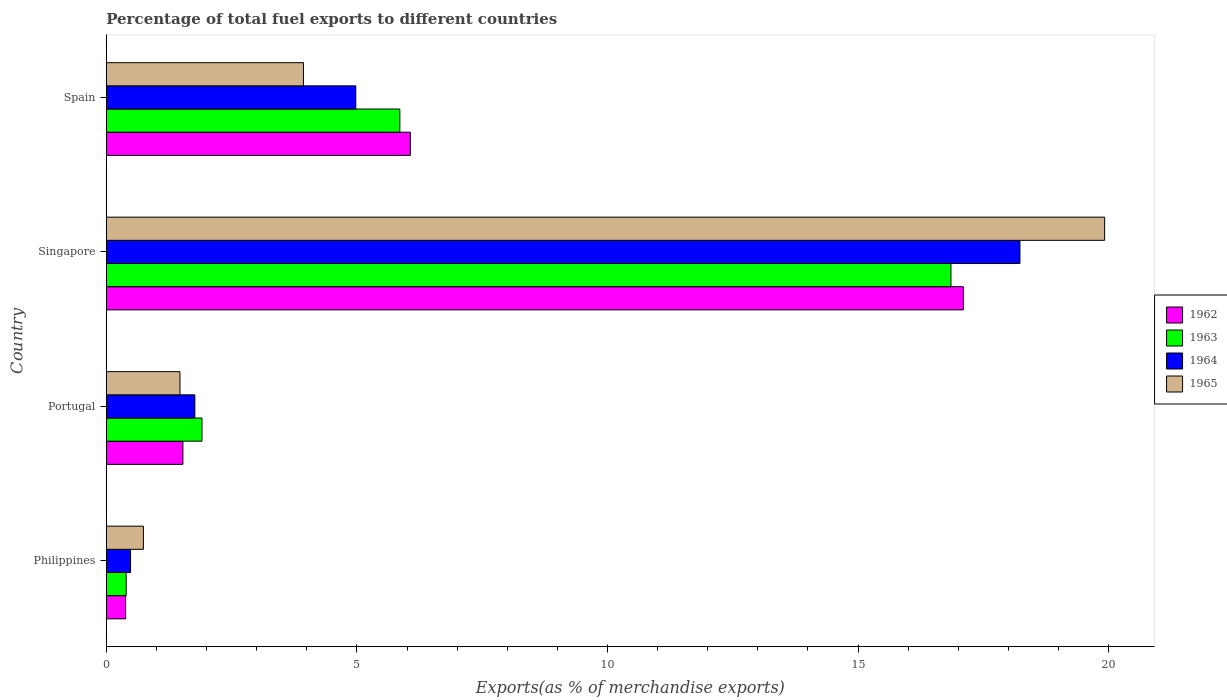How many different coloured bars are there?
Your answer should be very brief. 4. Are the number of bars per tick equal to the number of legend labels?
Ensure brevity in your answer.  Yes. How many bars are there on the 1st tick from the top?
Offer a terse response. 4. How many bars are there on the 3rd tick from the bottom?
Ensure brevity in your answer.  4. What is the label of the 2nd group of bars from the top?
Ensure brevity in your answer.  Singapore. What is the percentage of exports to different countries in 1962 in Philippines?
Give a very brief answer. 0.38. Across all countries, what is the maximum percentage of exports to different countries in 1965?
Offer a terse response. 19.92. Across all countries, what is the minimum percentage of exports to different countries in 1962?
Ensure brevity in your answer.  0.38. In which country was the percentage of exports to different countries in 1963 maximum?
Offer a terse response. Singapore. What is the total percentage of exports to different countries in 1965 in the graph?
Your answer should be compact. 26.06. What is the difference between the percentage of exports to different countries in 1965 in Philippines and that in Portugal?
Your response must be concise. -0.73. What is the difference between the percentage of exports to different countries in 1964 in Portugal and the percentage of exports to different countries in 1963 in Philippines?
Your answer should be compact. 1.37. What is the average percentage of exports to different countries in 1962 per country?
Provide a short and direct response. 6.27. What is the difference between the percentage of exports to different countries in 1964 and percentage of exports to different countries in 1965 in Portugal?
Offer a terse response. 0.3. What is the ratio of the percentage of exports to different countries in 1963 in Philippines to that in Spain?
Make the answer very short. 0.07. Is the percentage of exports to different countries in 1965 in Portugal less than that in Spain?
Your answer should be very brief. Yes. What is the difference between the highest and the second highest percentage of exports to different countries in 1962?
Provide a succinct answer. 11.04. What is the difference between the highest and the lowest percentage of exports to different countries in 1964?
Your answer should be very brief. 17.75. Is the sum of the percentage of exports to different countries in 1962 in Portugal and Singapore greater than the maximum percentage of exports to different countries in 1964 across all countries?
Your answer should be compact. Yes. Is it the case that in every country, the sum of the percentage of exports to different countries in 1962 and percentage of exports to different countries in 1963 is greater than the sum of percentage of exports to different countries in 1964 and percentage of exports to different countries in 1965?
Offer a terse response. No. What does the 4th bar from the bottom in Portugal represents?
Give a very brief answer. 1965. How many bars are there?
Your answer should be very brief. 16. Are all the bars in the graph horizontal?
Provide a short and direct response. Yes. What is the difference between two consecutive major ticks on the X-axis?
Provide a short and direct response. 5. Are the values on the major ticks of X-axis written in scientific E-notation?
Offer a terse response. No. Does the graph contain any zero values?
Your answer should be compact. No. Where does the legend appear in the graph?
Your response must be concise. Center right. What is the title of the graph?
Offer a very short reply. Percentage of total fuel exports to different countries. Does "2013" appear as one of the legend labels in the graph?
Give a very brief answer. No. What is the label or title of the X-axis?
Keep it short and to the point. Exports(as % of merchandise exports). What is the label or title of the Y-axis?
Provide a short and direct response. Country. What is the Exports(as % of merchandise exports) of 1962 in Philippines?
Offer a very short reply. 0.38. What is the Exports(as % of merchandise exports) of 1963 in Philippines?
Give a very brief answer. 0.4. What is the Exports(as % of merchandise exports) of 1964 in Philippines?
Your response must be concise. 0.48. What is the Exports(as % of merchandise exports) of 1965 in Philippines?
Make the answer very short. 0.74. What is the Exports(as % of merchandise exports) of 1962 in Portugal?
Your response must be concise. 1.53. What is the Exports(as % of merchandise exports) of 1963 in Portugal?
Offer a terse response. 1.91. What is the Exports(as % of merchandise exports) of 1964 in Portugal?
Give a very brief answer. 1.77. What is the Exports(as % of merchandise exports) of 1965 in Portugal?
Keep it short and to the point. 1.47. What is the Exports(as % of merchandise exports) in 1962 in Singapore?
Ensure brevity in your answer.  17.1. What is the Exports(as % of merchandise exports) of 1963 in Singapore?
Your response must be concise. 16.85. What is the Exports(as % of merchandise exports) of 1964 in Singapore?
Give a very brief answer. 18.23. What is the Exports(as % of merchandise exports) of 1965 in Singapore?
Offer a very short reply. 19.92. What is the Exports(as % of merchandise exports) of 1962 in Spain?
Offer a terse response. 6.07. What is the Exports(as % of merchandise exports) in 1963 in Spain?
Provide a succinct answer. 5.86. What is the Exports(as % of merchandise exports) of 1964 in Spain?
Your response must be concise. 4.98. What is the Exports(as % of merchandise exports) in 1965 in Spain?
Your answer should be compact. 3.93. Across all countries, what is the maximum Exports(as % of merchandise exports) of 1962?
Your answer should be compact. 17.1. Across all countries, what is the maximum Exports(as % of merchandise exports) of 1963?
Provide a succinct answer. 16.85. Across all countries, what is the maximum Exports(as % of merchandise exports) in 1964?
Offer a very short reply. 18.23. Across all countries, what is the maximum Exports(as % of merchandise exports) of 1965?
Keep it short and to the point. 19.92. Across all countries, what is the minimum Exports(as % of merchandise exports) of 1962?
Give a very brief answer. 0.38. Across all countries, what is the minimum Exports(as % of merchandise exports) of 1963?
Make the answer very short. 0.4. Across all countries, what is the minimum Exports(as % of merchandise exports) in 1964?
Offer a terse response. 0.48. Across all countries, what is the minimum Exports(as % of merchandise exports) of 1965?
Keep it short and to the point. 0.74. What is the total Exports(as % of merchandise exports) of 1962 in the graph?
Give a very brief answer. 25.08. What is the total Exports(as % of merchandise exports) in 1963 in the graph?
Ensure brevity in your answer.  25.02. What is the total Exports(as % of merchandise exports) in 1964 in the graph?
Give a very brief answer. 25.46. What is the total Exports(as % of merchandise exports) in 1965 in the graph?
Keep it short and to the point. 26.07. What is the difference between the Exports(as % of merchandise exports) in 1962 in Philippines and that in Portugal?
Your response must be concise. -1.14. What is the difference between the Exports(as % of merchandise exports) in 1963 in Philippines and that in Portugal?
Make the answer very short. -1.51. What is the difference between the Exports(as % of merchandise exports) of 1964 in Philippines and that in Portugal?
Your response must be concise. -1.28. What is the difference between the Exports(as % of merchandise exports) of 1965 in Philippines and that in Portugal?
Your answer should be compact. -0.73. What is the difference between the Exports(as % of merchandise exports) of 1962 in Philippines and that in Singapore?
Give a very brief answer. -16.72. What is the difference between the Exports(as % of merchandise exports) of 1963 in Philippines and that in Singapore?
Provide a short and direct response. -16.46. What is the difference between the Exports(as % of merchandise exports) in 1964 in Philippines and that in Singapore?
Your response must be concise. -17.75. What is the difference between the Exports(as % of merchandise exports) of 1965 in Philippines and that in Singapore?
Your answer should be compact. -19.18. What is the difference between the Exports(as % of merchandise exports) in 1962 in Philippines and that in Spain?
Your answer should be compact. -5.68. What is the difference between the Exports(as % of merchandise exports) of 1963 in Philippines and that in Spain?
Ensure brevity in your answer.  -5.46. What is the difference between the Exports(as % of merchandise exports) of 1964 in Philippines and that in Spain?
Offer a terse response. -4.49. What is the difference between the Exports(as % of merchandise exports) of 1965 in Philippines and that in Spain?
Provide a short and direct response. -3.19. What is the difference between the Exports(as % of merchandise exports) in 1962 in Portugal and that in Singapore?
Provide a succinct answer. -15.58. What is the difference between the Exports(as % of merchandise exports) in 1963 in Portugal and that in Singapore?
Provide a succinct answer. -14.95. What is the difference between the Exports(as % of merchandise exports) of 1964 in Portugal and that in Singapore?
Keep it short and to the point. -16.47. What is the difference between the Exports(as % of merchandise exports) in 1965 in Portugal and that in Singapore?
Offer a very short reply. -18.45. What is the difference between the Exports(as % of merchandise exports) of 1962 in Portugal and that in Spain?
Make the answer very short. -4.54. What is the difference between the Exports(as % of merchandise exports) in 1963 in Portugal and that in Spain?
Provide a succinct answer. -3.95. What is the difference between the Exports(as % of merchandise exports) of 1964 in Portugal and that in Spain?
Make the answer very short. -3.21. What is the difference between the Exports(as % of merchandise exports) of 1965 in Portugal and that in Spain?
Your answer should be compact. -2.46. What is the difference between the Exports(as % of merchandise exports) of 1962 in Singapore and that in Spain?
Your response must be concise. 11.04. What is the difference between the Exports(as % of merchandise exports) of 1963 in Singapore and that in Spain?
Offer a very short reply. 11. What is the difference between the Exports(as % of merchandise exports) of 1964 in Singapore and that in Spain?
Offer a terse response. 13.25. What is the difference between the Exports(as % of merchandise exports) of 1965 in Singapore and that in Spain?
Keep it short and to the point. 15.99. What is the difference between the Exports(as % of merchandise exports) of 1962 in Philippines and the Exports(as % of merchandise exports) of 1963 in Portugal?
Provide a succinct answer. -1.52. What is the difference between the Exports(as % of merchandise exports) of 1962 in Philippines and the Exports(as % of merchandise exports) of 1964 in Portugal?
Give a very brief answer. -1.38. What is the difference between the Exports(as % of merchandise exports) of 1962 in Philippines and the Exports(as % of merchandise exports) of 1965 in Portugal?
Offer a very short reply. -1.08. What is the difference between the Exports(as % of merchandise exports) of 1963 in Philippines and the Exports(as % of merchandise exports) of 1964 in Portugal?
Provide a succinct answer. -1.37. What is the difference between the Exports(as % of merchandise exports) in 1963 in Philippines and the Exports(as % of merchandise exports) in 1965 in Portugal?
Your answer should be compact. -1.07. What is the difference between the Exports(as % of merchandise exports) in 1964 in Philippines and the Exports(as % of merchandise exports) in 1965 in Portugal?
Ensure brevity in your answer.  -0.99. What is the difference between the Exports(as % of merchandise exports) of 1962 in Philippines and the Exports(as % of merchandise exports) of 1963 in Singapore?
Offer a very short reply. -16.47. What is the difference between the Exports(as % of merchandise exports) of 1962 in Philippines and the Exports(as % of merchandise exports) of 1964 in Singapore?
Ensure brevity in your answer.  -17.85. What is the difference between the Exports(as % of merchandise exports) of 1962 in Philippines and the Exports(as % of merchandise exports) of 1965 in Singapore?
Provide a short and direct response. -19.54. What is the difference between the Exports(as % of merchandise exports) of 1963 in Philippines and the Exports(as % of merchandise exports) of 1964 in Singapore?
Provide a succinct answer. -17.84. What is the difference between the Exports(as % of merchandise exports) in 1963 in Philippines and the Exports(as % of merchandise exports) in 1965 in Singapore?
Ensure brevity in your answer.  -19.53. What is the difference between the Exports(as % of merchandise exports) in 1964 in Philippines and the Exports(as % of merchandise exports) in 1965 in Singapore?
Offer a terse response. -19.44. What is the difference between the Exports(as % of merchandise exports) of 1962 in Philippines and the Exports(as % of merchandise exports) of 1963 in Spain?
Give a very brief answer. -5.47. What is the difference between the Exports(as % of merchandise exports) in 1962 in Philippines and the Exports(as % of merchandise exports) in 1964 in Spain?
Make the answer very short. -4.59. What is the difference between the Exports(as % of merchandise exports) in 1962 in Philippines and the Exports(as % of merchandise exports) in 1965 in Spain?
Your response must be concise. -3.55. What is the difference between the Exports(as % of merchandise exports) in 1963 in Philippines and the Exports(as % of merchandise exports) in 1964 in Spain?
Offer a very short reply. -4.58. What is the difference between the Exports(as % of merchandise exports) in 1963 in Philippines and the Exports(as % of merchandise exports) in 1965 in Spain?
Give a very brief answer. -3.54. What is the difference between the Exports(as % of merchandise exports) in 1964 in Philippines and the Exports(as % of merchandise exports) in 1965 in Spain?
Make the answer very short. -3.45. What is the difference between the Exports(as % of merchandise exports) in 1962 in Portugal and the Exports(as % of merchandise exports) in 1963 in Singapore?
Provide a short and direct response. -15.33. What is the difference between the Exports(as % of merchandise exports) in 1962 in Portugal and the Exports(as % of merchandise exports) in 1964 in Singapore?
Ensure brevity in your answer.  -16.7. What is the difference between the Exports(as % of merchandise exports) in 1962 in Portugal and the Exports(as % of merchandise exports) in 1965 in Singapore?
Your answer should be very brief. -18.39. What is the difference between the Exports(as % of merchandise exports) in 1963 in Portugal and the Exports(as % of merchandise exports) in 1964 in Singapore?
Your response must be concise. -16.32. What is the difference between the Exports(as % of merchandise exports) in 1963 in Portugal and the Exports(as % of merchandise exports) in 1965 in Singapore?
Your answer should be very brief. -18.01. What is the difference between the Exports(as % of merchandise exports) in 1964 in Portugal and the Exports(as % of merchandise exports) in 1965 in Singapore?
Your response must be concise. -18.16. What is the difference between the Exports(as % of merchandise exports) of 1962 in Portugal and the Exports(as % of merchandise exports) of 1963 in Spain?
Your answer should be very brief. -4.33. What is the difference between the Exports(as % of merchandise exports) of 1962 in Portugal and the Exports(as % of merchandise exports) of 1964 in Spain?
Offer a very short reply. -3.45. What is the difference between the Exports(as % of merchandise exports) in 1962 in Portugal and the Exports(as % of merchandise exports) in 1965 in Spain?
Your answer should be very brief. -2.41. What is the difference between the Exports(as % of merchandise exports) of 1963 in Portugal and the Exports(as % of merchandise exports) of 1964 in Spain?
Offer a very short reply. -3.07. What is the difference between the Exports(as % of merchandise exports) in 1963 in Portugal and the Exports(as % of merchandise exports) in 1965 in Spain?
Provide a succinct answer. -2.03. What is the difference between the Exports(as % of merchandise exports) of 1964 in Portugal and the Exports(as % of merchandise exports) of 1965 in Spain?
Make the answer very short. -2.17. What is the difference between the Exports(as % of merchandise exports) in 1962 in Singapore and the Exports(as % of merchandise exports) in 1963 in Spain?
Provide a succinct answer. 11.25. What is the difference between the Exports(as % of merchandise exports) in 1962 in Singapore and the Exports(as % of merchandise exports) in 1964 in Spain?
Offer a very short reply. 12.13. What is the difference between the Exports(as % of merchandise exports) in 1962 in Singapore and the Exports(as % of merchandise exports) in 1965 in Spain?
Provide a short and direct response. 13.17. What is the difference between the Exports(as % of merchandise exports) of 1963 in Singapore and the Exports(as % of merchandise exports) of 1964 in Spain?
Your response must be concise. 11.88. What is the difference between the Exports(as % of merchandise exports) of 1963 in Singapore and the Exports(as % of merchandise exports) of 1965 in Spain?
Ensure brevity in your answer.  12.92. What is the difference between the Exports(as % of merchandise exports) of 1964 in Singapore and the Exports(as % of merchandise exports) of 1965 in Spain?
Offer a terse response. 14.3. What is the average Exports(as % of merchandise exports) of 1962 per country?
Your answer should be compact. 6.27. What is the average Exports(as % of merchandise exports) in 1963 per country?
Your response must be concise. 6.25. What is the average Exports(as % of merchandise exports) in 1964 per country?
Offer a terse response. 6.37. What is the average Exports(as % of merchandise exports) of 1965 per country?
Make the answer very short. 6.52. What is the difference between the Exports(as % of merchandise exports) of 1962 and Exports(as % of merchandise exports) of 1963 in Philippines?
Give a very brief answer. -0.01. What is the difference between the Exports(as % of merchandise exports) of 1962 and Exports(as % of merchandise exports) of 1964 in Philippines?
Ensure brevity in your answer.  -0.1. What is the difference between the Exports(as % of merchandise exports) of 1962 and Exports(as % of merchandise exports) of 1965 in Philippines?
Your response must be concise. -0.35. What is the difference between the Exports(as % of merchandise exports) in 1963 and Exports(as % of merchandise exports) in 1964 in Philippines?
Keep it short and to the point. -0.09. What is the difference between the Exports(as % of merchandise exports) of 1963 and Exports(as % of merchandise exports) of 1965 in Philippines?
Make the answer very short. -0.34. What is the difference between the Exports(as % of merchandise exports) in 1964 and Exports(as % of merchandise exports) in 1965 in Philippines?
Your answer should be compact. -0.26. What is the difference between the Exports(as % of merchandise exports) of 1962 and Exports(as % of merchandise exports) of 1963 in Portugal?
Ensure brevity in your answer.  -0.38. What is the difference between the Exports(as % of merchandise exports) of 1962 and Exports(as % of merchandise exports) of 1964 in Portugal?
Provide a succinct answer. -0.24. What is the difference between the Exports(as % of merchandise exports) in 1962 and Exports(as % of merchandise exports) in 1965 in Portugal?
Make the answer very short. 0.06. What is the difference between the Exports(as % of merchandise exports) in 1963 and Exports(as % of merchandise exports) in 1964 in Portugal?
Provide a succinct answer. 0.14. What is the difference between the Exports(as % of merchandise exports) in 1963 and Exports(as % of merchandise exports) in 1965 in Portugal?
Your response must be concise. 0.44. What is the difference between the Exports(as % of merchandise exports) in 1964 and Exports(as % of merchandise exports) in 1965 in Portugal?
Keep it short and to the point. 0.3. What is the difference between the Exports(as % of merchandise exports) in 1962 and Exports(as % of merchandise exports) in 1963 in Singapore?
Keep it short and to the point. 0.25. What is the difference between the Exports(as % of merchandise exports) of 1962 and Exports(as % of merchandise exports) of 1964 in Singapore?
Provide a short and direct response. -1.13. What is the difference between the Exports(as % of merchandise exports) in 1962 and Exports(as % of merchandise exports) in 1965 in Singapore?
Your response must be concise. -2.82. What is the difference between the Exports(as % of merchandise exports) of 1963 and Exports(as % of merchandise exports) of 1964 in Singapore?
Keep it short and to the point. -1.38. What is the difference between the Exports(as % of merchandise exports) in 1963 and Exports(as % of merchandise exports) in 1965 in Singapore?
Your answer should be very brief. -3.07. What is the difference between the Exports(as % of merchandise exports) of 1964 and Exports(as % of merchandise exports) of 1965 in Singapore?
Your answer should be compact. -1.69. What is the difference between the Exports(as % of merchandise exports) of 1962 and Exports(as % of merchandise exports) of 1963 in Spain?
Provide a short and direct response. 0.21. What is the difference between the Exports(as % of merchandise exports) of 1962 and Exports(as % of merchandise exports) of 1964 in Spain?
Make the answer very short. 1.09. What is the difference between the Exports(as % of merchandise exports) in 1962 and Exports(as % of merchandise exports) in 1965 in Spain?
Provide a succinct answer. 2.13. What is the difference between the Exports(as % of merchandise exports) in 1963 and Exports(as % of merchandise exports) in 1964 in Spain?
Provide a short and direct response. 0.88. What is the difference between the Exports(as % of merchandise exports) in 1963 and Exports(as % of merchandise exports) in 1965 in Spain?
Provide a succinct answer. 1.92. What is the difference between the Exports(as % of merchandise exports) of 1964 and Exports(as % of merchandise exports) of 1965 in Spain?
Make the answer very short. 1.04. What is the ratio of the Exports(as % of merchandise exports) of 1962 in Philippines to that in Portugal?
Your response must be concise. 0.25. What is the ratio of the Exports(as % of merchandise exports) of 1963 in Philippines to that in Portugal?
Provide a short and direct response. 0.21. What is the ratio of the Exports(as % of merchandise exports) in 1964 in Philippines to that in Portugal?
Offer a terse response. 0.27. What is the ratio of the Exports(as % of merchandise exports) of 1965 in Philippines to that in Portugal?
Your answer should be compact. 0.5. What is the ratio of the Exports(as % of merchandise exports) of 1962 in Philippines to that in Singapore?
Keep it short and to the point. 0.02. What is the ratio of the Exports(as % of merchandise exports) in 1963 in Philippines to that in Singapore?
Your answer should be very brief. 0.02. What is the ratio of the Exports(as % of merchandise exports) in 1964 in Philippines to that in Singapore?
Your response must be concise. 0.03. What is the ratio of the Exports(as % of merchandise exports) in 1965 in Philippines to that in Singapore?
Give a very brief answer. 0.04. What is the ratio of the Exports(as % of merchandise exports) of 1962 in Philippines to that in Spain?
Give a very brief answer. 0.06. What is the ratio of the Exports(as % of merchandise exports) of 1963 in Philippines to that in Spain?
Offer a very short reply. 0.07. What is the ratio of the Exports(as % of merchandise exports) in 1964 in Philippines to that in Spain?
Provide a short and direct response. 0.1. What is the ratio of the Exports(as % of merchandise exports) of 1965 in Philippines to that in Spain?
Offer a very short reply. 0.19. What is the ratio of the Exports(as % of merchandise exports) in 1962 in Portugal to that in Singapore?
Ensure brevity in your answer.  0.09. What is the ratio of the Exports(as % of merchandise exports) of 1963 in Portugal to that in Singapore?
Offer a terse response. 0.11. What is the ratio of the Exports(as % of merchandise exports) in 1964 in Portugal to that in Singapore?
Provide a short and direct response. 0.1. What is the ratio of the Exports(as % of merchandise exports) of 1965 in Portugal to that in Singapore?
Give a very brief answer. 0.07. What is the ratio of the Exports(as % of merchandise exports) in 1962 in Portugal to that in Spain?
Keep it short and to the point. 0.25. What is the ratio of the Exports(as % of merchandise exports) of 1963 in Portugal to that in Spain?
Offer a very short reply. 0.33. What is the ratio of the Exports(as % of merchandise exports) of 1964 in Portugal to that in Spain?
Provide a short and direct response. 0.35. What is the ratio of the Exports(as % of merchandise exports) in 1965 in Portugal to that in Spain?
Your answer should be very brief. 0.37. What is the ratio of the Exports(as % of merchandise exports) in 1962 in Singapore to that in Spain?
Offer a terse response. 2.82. What is the ratio of the Exports(as % of merchandise exports) of 1963 in Singapore to that in Spain?
Give a very brief answer. 2.88. What is the ratio of the Exports(as % of merchandise exports) in 1964 in Singapore to that in Spain?
Your answer should be compact. 3.66. What is the ratio of the Exports(as % of merchandise exports) in 1965 in Singapore to that in Spain?
Offer a very short reply. 5.06. What is the difference between the highest and the second highest Exports(as % of merchandise exports) of 1962?
Offer a terse response. 11.04. What is the difference between the highest and the second highest Exports(as % of merchandise exports) of 1963?
Your answer should be compact. 11. What is the difference between the highest and the second highest Exports(as % of merchandise exports) of 1964?
Make the answer very short. 13.25. What is the difference between the highest and the second highest Exports(as % of merchandise exports) in 1965?
Make the answer very short. 15.99. What is the difference between the highest and the lowest Exports(as % of merchandise exports) in 1962?
Your answer should be very brief. 16.72. What is the difference between the highest and the lowest Exports(as % of merchandise exports) of 1963?
Your answer should be very brief. 16.46. What is the difference between the highest and the lowest Exports(as % of merchandise exports) in 1964?
Offer a terse response. 17.75. What is the difference between the highest and the lowest Exports(as % of merchandise exports) of 1965?
Your response must be concise. 19.18. 